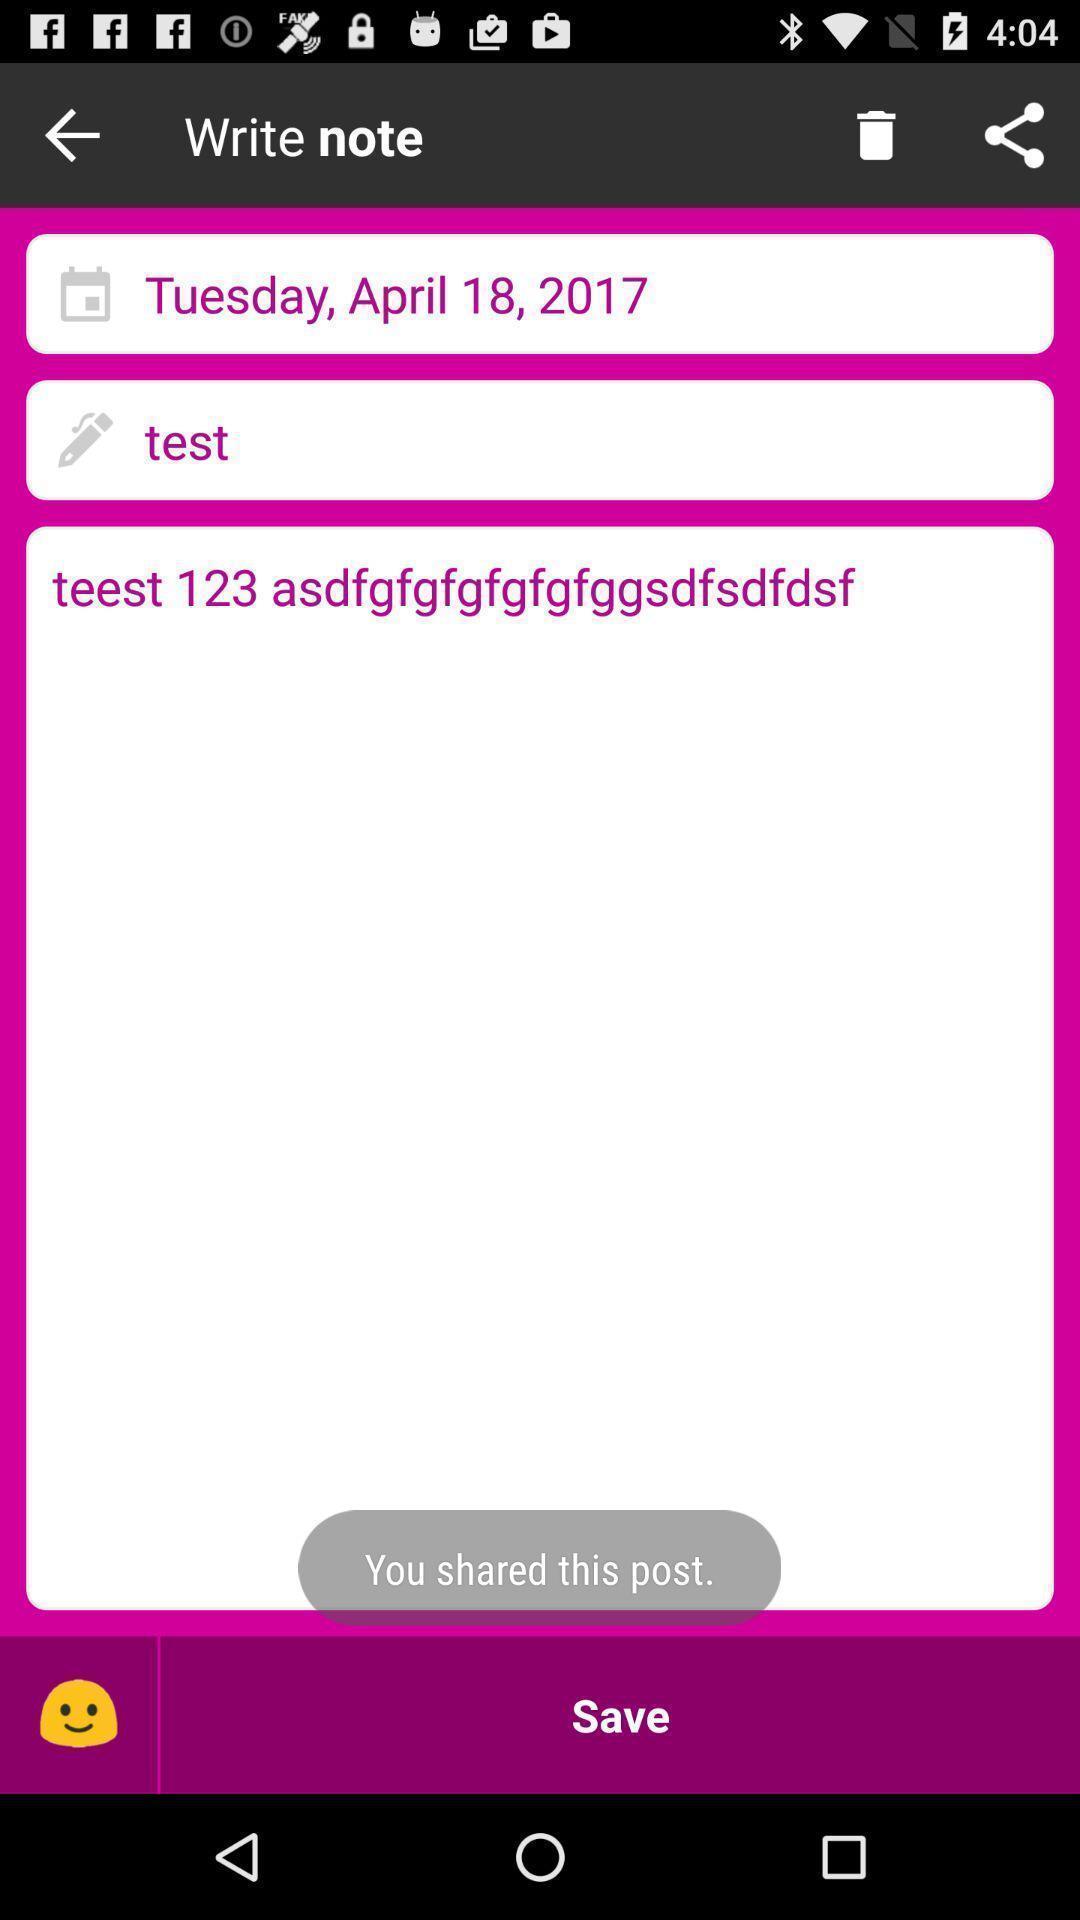What details can you identify in this image? Shared the post in write note. 